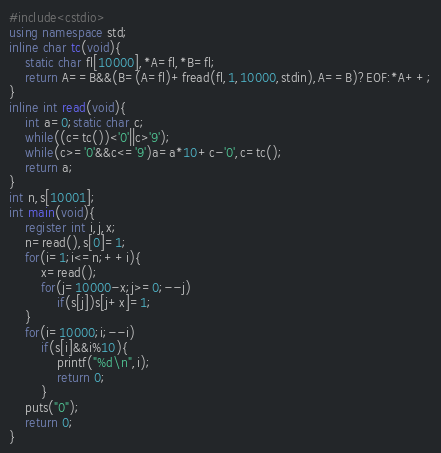<code> <loc_0><loc_0><loc_500><loc_500><_C++_>#include<cstdio>
using namespace std;
inline char tc(void){
	static char fl[10000],*A=fl,*B=fl;
	return A==B&&(B=(A=fl)+fread(fl,1,10000,stdin),A==B)?EOF:*A++;
}
inline int read(void){
	int a=0;static char c;
	while((c=tc())<'0'||c>'9');
	while(c>='0'&&c<='9')a=a*10+c-'0',c=tc();
	return a;
}
int n,s[10001];
int main(void){
	register int i,j,x;
	n=read(),s[0]=1;
	for(i=1;i<=n;++i){
		x=read();
		for(j=10000-x;j>=0;--j)	
			if(s[j])s[j+x]=1;
	}
	for(i=10000;i;--i)
		if(s[i]&&i%10){
			printf("%d\n",i);
			return 0;
		}
	puts("0");
	return 0;
}</code> 